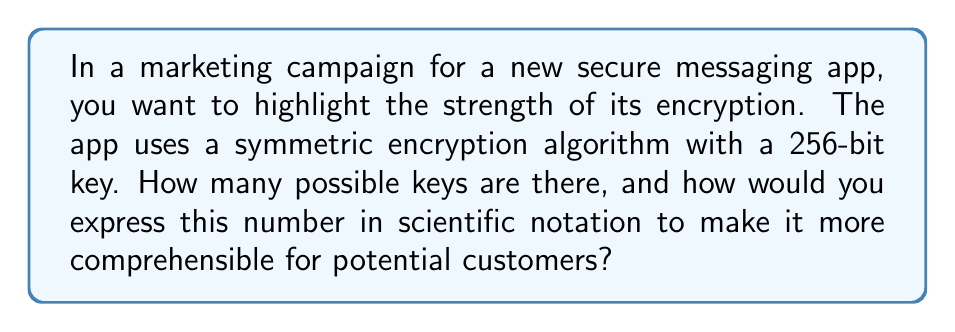Teach me how to tackle this problem. To calculate the key space for a symmetric encryption algorithm with a 256-bit key, we need to follow these steps:

1. Understand that each bit in the key can have two possible values: 0 or 1.

2. Calculate the total number of possible combinations:
   For a 256-bit key, we have 2 choices for each of the 256 bits.
   This can be expressed as: $2^{256}$

3. Calculate the result:
   $2^{256} = 115,792,089,237,316,195,423,570,985,008,687,907,853,269,984,665,640,564,039,457,584,007,913,129,639,936$

4. Convert to scientific notation:
   $2^{256} \approx 1.1579 \times 10^{77}$

To make this more comprehensible for potential customers, we can compare it to something familiar:

5. The number of atoms in the observable universe is estimated to be around $10^{80}$.

So, we can say that the number of possible keys is roughly equivalent to 1/1000th of the number of atoms in the observable universe.
Answer: $1.1579 \times 10^{77}$ keys 